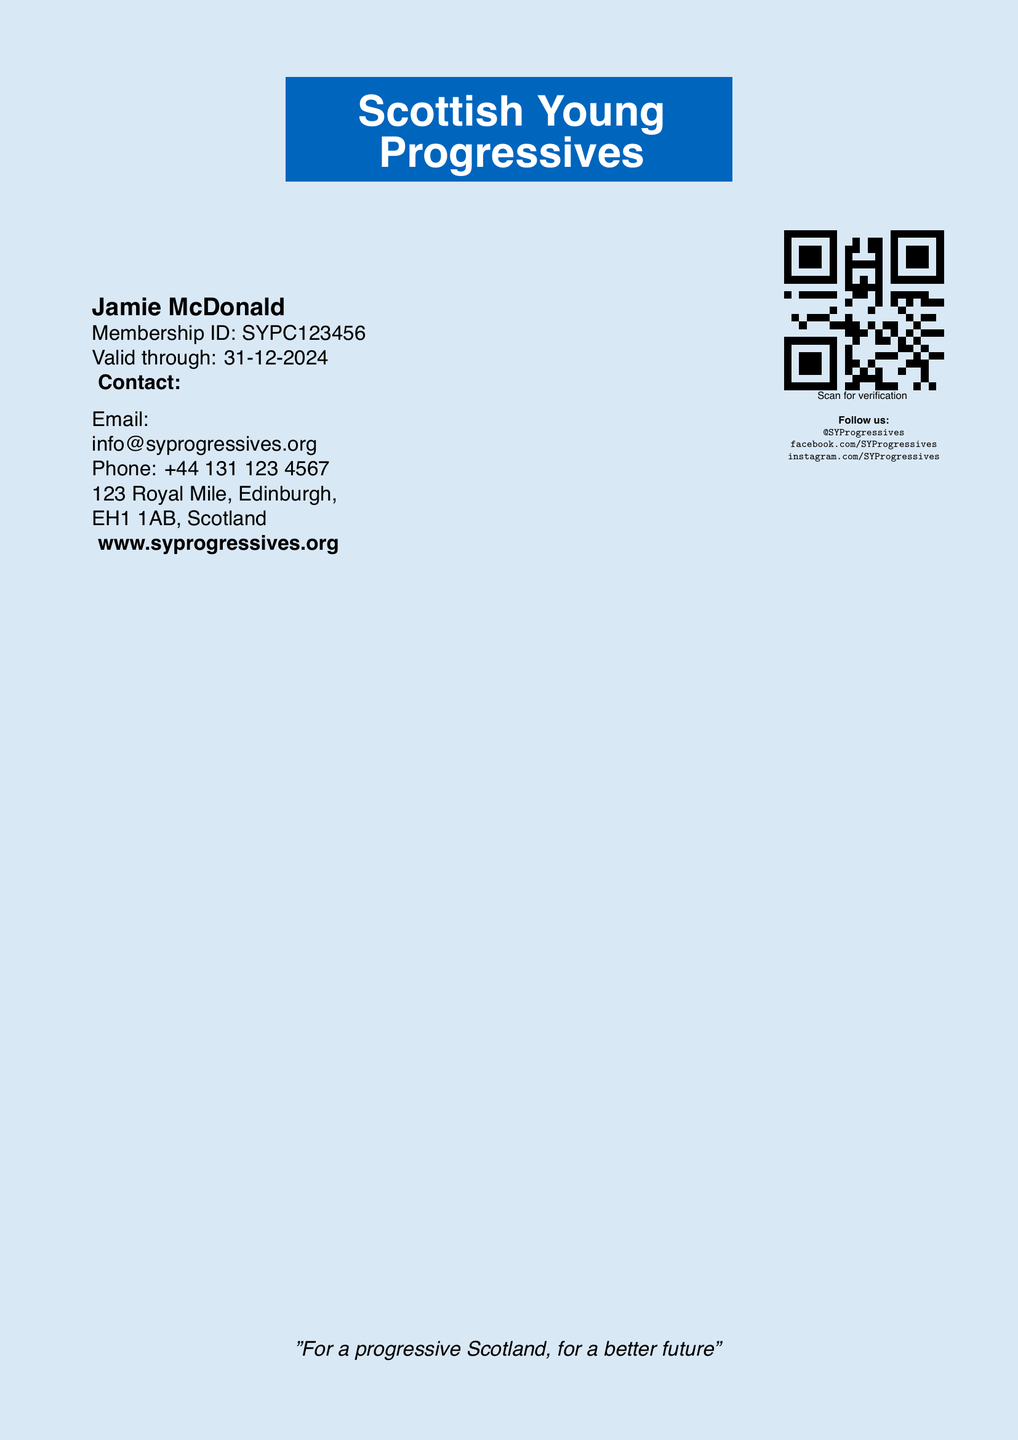What is the name of the group? The name of the group is prominently displayed at the top of the document.
Answer: Scottish Young Progressives What is the membership ID? The Membership ID is located under the member's name on the card.
Answer: SYPC123456 What is the validity date of the membership? The validity date is stated clearly on the card.
Answer: 31-12-2024 What is the email contact provided? The email address can be found in the contact section of the document.
Answer: info@syprogressives.org What is the address listed on the card? The address is provided in the contact section of the card.
Answer: 123 Royal Mile, Edinburgh, EH1 1AB, Scotland What does the QR code signify? The QR code is used for verification purposes as stated below it.
Answer: Scan for verification How many social media platforms are mentioned? The card lists three social media platforms for following the group.
Answer: Three What is the color scheme used in the card? The overall color scheme is indicated by the background and text colors.
Answer: Blue and white What is the message at the bottom of the card? A motto or slogan is included at the bottom of the card for emphasis.
Answer: "For a progressive Scotland, for a better future" 